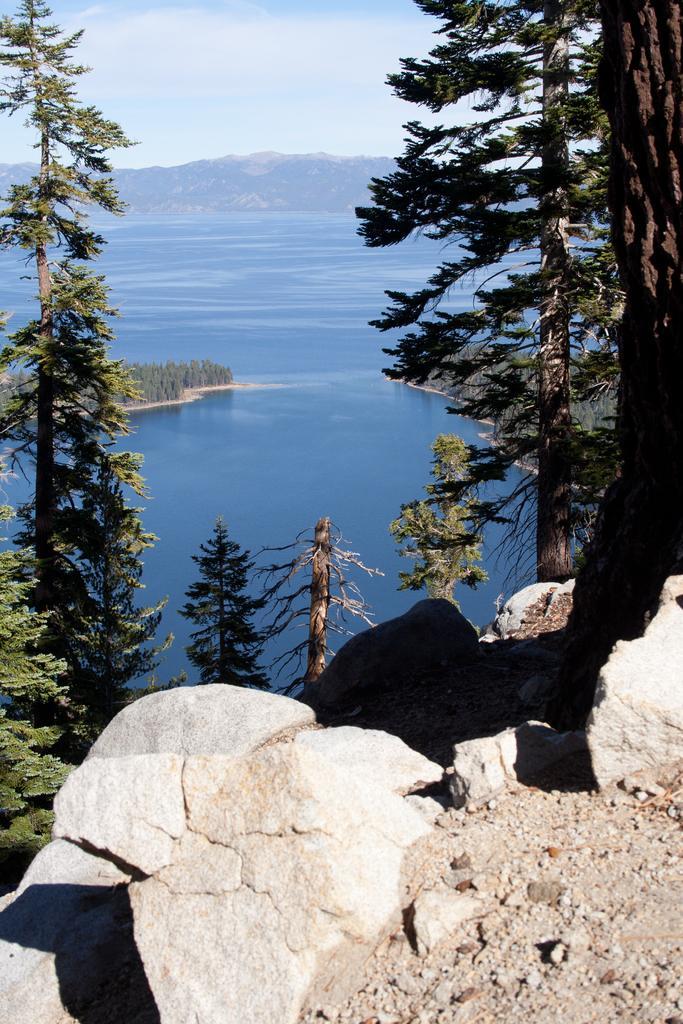Can you describe this image briefly? At the bottom of the image there are stones. In the background of the image there are mountains,sky,water. In the foreground of the image there are trees. 